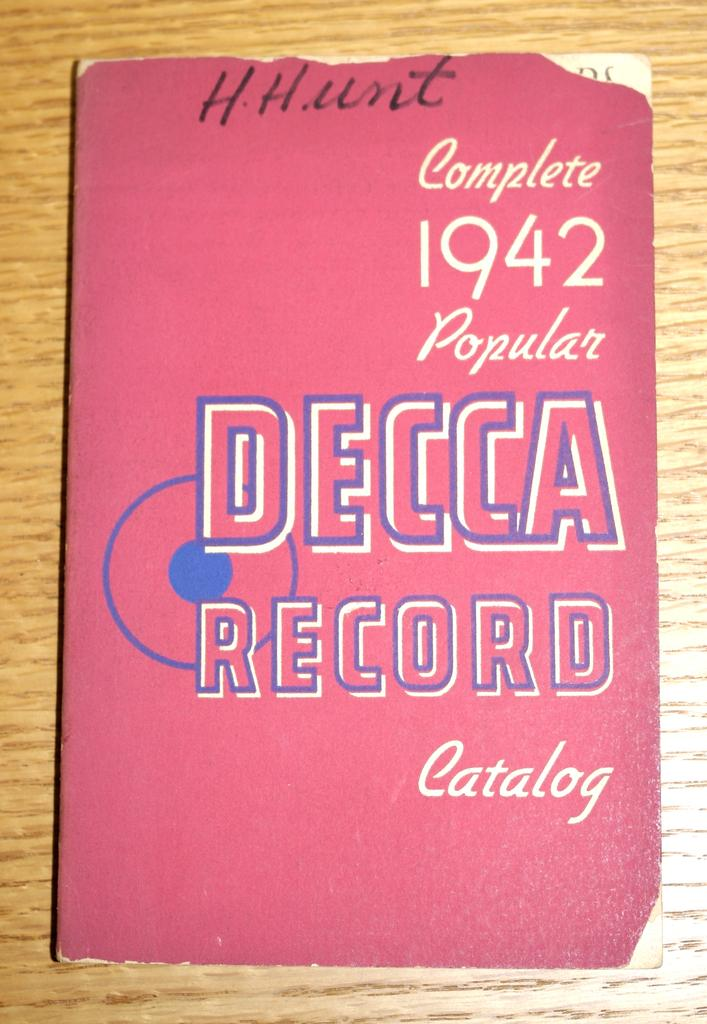What type of furniture is present in the image? There is a table in the image. What object is placed on the table? There is a book on the table. What type of pet can be seen playing with a marble on the table in the image? There is no pet or marble present on the table in the image; only a book is visible. 